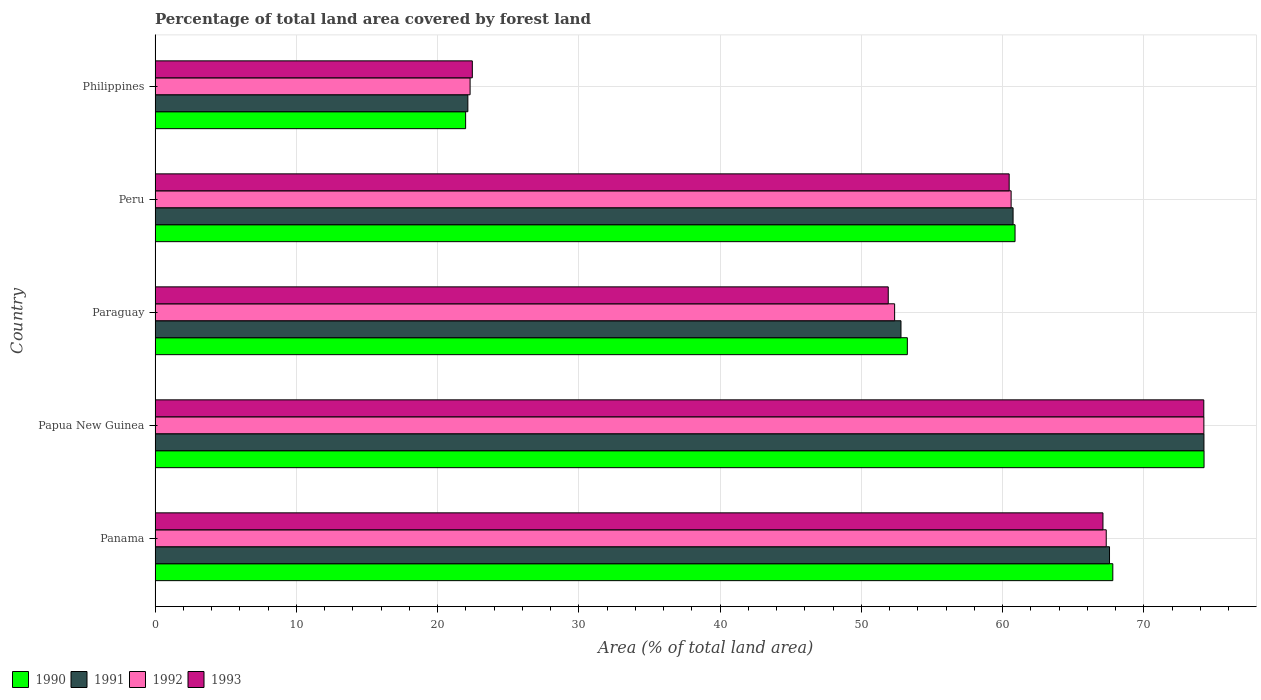Are the number of bars per tick equal to the number of legend labels?
Your answer should be very brief. Yes. How many bars are there on the 1st tick from the top?
Your response must be concise. 4. What is the label of the 3rd group of bars from the top?
Provide a short and direct response. Paraguay. In how many cases, is the number of bars for a given country not equal to the number of legend labels?
Provide a short and direct response. 0. What is the percentage of forest land in 1992 in Peru?
Offer a terse response. 60.6. Across all countries, what is the maximum percentage of forest land in 1993?
Ensure brevity in your answer.  74.24. Across all countries, what is the minimum percentage of forest land in 1990?
Your response must be concise. 21.98. In which country was the percentage of forest land in 1992 maximum?
Offer a terse response. Papua New Guinea. In which country was the percentage of forest land in 1992 minimum?
Your answer should be very brief. Philippines. What is the total percentage of forest land in 1991 in the graph?
Provide a short and direct response. 277.49. What is the difference between the percentage of forest land in 1993 in Panama and that in Peru?
Your answer should be very brief. 6.64. What is the difference between the percentage of forest land in 1991 in Peru and the percentage of forest land in 1993 in Philippines?
Your answer should be compact. 38.28. What is the average percentage of forest land in 1992 per country?
Keep it short and to the point. 55.36. What is the difference between the percentage of forest land in 1993 and percentage of forest land in 1991 in Papua New Guinea?
Your response must be concise. -0.01. In how many countries, is the percentage of forest land in 1991 greater than 58 %?
Keep it short and to the point. 3. What is the ratio of the percentage of forest land in 1991 in Panama to that in Paraguay?
Offer a terse response. 1.28. Is the percentage of forest land in 1992 in Peru less than that in Philippines?
Your answer should be very brief. No. What is the difference between the highest and the second highest percentage of forest land in 1990?
Keep it short and to the point. 6.46. What is the difference between the highest and the lowest percentage of forest land in 1991?
Keep it short and to the point. 52.11. In how many countries, is the percentage of forest land in 1990 greater than the average percentage of forest land in 1990 taken over all countries?
Your response must be concise. 3. Is the sum of the percentage of forest land in 1990 in Panama and Peru greater than the maximum percentage of forest land in 1992 across all countries?
Your response must be concise. Yes. What does the 3rd bar from the top in Philippines represents?
Your response must be concise. 1991. What does the 4th bar from the bottom in Papua New Guinea represents?
Ensure brevity in your answer.  1993. Is it the case that in every country, the sum of the percentage of forest land in 1993 and percentage of forest land in 1992 is greater than the percentage of forest land in 1990?
Provide a short and direct response. Yes. How many bars are there?
Offer a very short reply. 20. What is the difference between two consecutive major ticks on the X-axis?
Keep it short and to the point. 10. Are the values on the major ticks of X-axis written in scientific E-notation?
Offer a terse response. No. Does the graph contain grids?
Make the answer very short. Yes. What is the title of the graph?
Provide a succinct answer. Percentage of total land area covered by forest land. Does "2012" appear as one of the legend labels in the graph?
Your answer should be compact. No. What is the label or title of the X-axis?
Provide a short and direct response. Area (% of total land area). What is the Area (% of total land area) in 1990 in Panama?
Your answer should be compact. 67.8. What is the Area (% of total land area) in 1991 in Panama?
Provide a succinct answer. 67.56. What is the Area (% of total land area) of 1992 in Panama?
Provide a short and direct response. 67.33. What is the Area (% of total land area) of 1993 in Panama?
Your response must be concise. 67.1. What is the Area (% of total land area) of 1990 in Papua New Guinea?
Give a very brief answer. 74.25. What is the Area (% of total land area) in 1991 in Papua New Guinea?
Ensure brevity in your answer.  74.25. What is the Area (% of total land area) in 1992 in Papua New Guinea?
Offer a very short reply. 74.24. What is the Area (% of total land area) in 1993 in Papua New Guinea?
Give a very brief answer. 74.24. What is the Area (% of total land area) of 1990 in Paraguay?
Make the answer very short. 53.25. What is the Area (% of total land area) of 1991 in Paraguay?
Make the answer very short. 52.8. What is the Area (% of total land area) of 1992 in Paraguay?
Ensure brevity in your answer.  52.35. What is the Area (% of total land area) of 1993 in Paraguay?
Offer a terse response. 51.9. What is the Area (% of total land area) of 1990 in Peru?
Ensure brevity in your answer.  60.88. What is the Area (% of total land area) of 1991 in Peru?
Make the answer very short. 60.74. What is the Area (% of total land area) of 1992 in Peru?
Give a very brief answer. 60.6. What is the Area (% of total land area) in 1993 in Peru?
Your answer should be compact. 60.46. What is the Area (% of total land area) of 1990 in Philippines?
Ensure brevity in your answer.  21.98. What is the Area (% of total land area) in 1991 in Philippines?
Keep it short and to the point. 22.14. What is the Area (% of total land area) in 1992 in Philippines?
Keep it short and to the point. 22.3. What is the Area (% of total land area) in 1993 in Philippines?
Ensure brevity in your answer.  22.46. Across all countries, what is the maximum Area (% of total land area) of 1990?
Offer a terse response. 74.25. Across all countries, what is the maximum Area (% of total land area) of 1991?
Offer a terse response. 74.25. Across all countries, what is the maximum Area (% of total land area) of 1992?
Your answer should be compact. 74.24. Across all countries, what is the maximum Area (% of total land area) of 1993?
Make the answer very short. 74.24. Across all countries, what is the minimum Area (% of total land area) of 1990?
Offer a terse response. 21.98. Across all countries, what is the minimum Area (% of total land area) of 1991?
Your answer should be compact. 22.14. Across all countries, what is the minimum Area (% of total land area) in 1992?
Offer a very short reply. 22.3. Across all countries, what is the minimum Area (% of total land area) in 1993?
Your answer should be very brief. 22.46. What is the total Area (% of total land area) of 1990 in the graph?
Ensure brevity in your answer.  278.16. What is the total Area (% of total land area) in 1991 in the graph?
Give a very brief answer. 277.49. What is the total Area (% of total land area) of 1992 in the graph?
Offer a terse response. 276.82. What is the total Area (% of total land area) in 1993 in the graph?
Ensure brevity in your answer.  276.16. What is the difference between the Area (% of total land area) in 1990 in Panama and that in Papua New Guinea?
Your answer should be very brief. -6.46. What is the difference between the Area (% of total land area) in 1991 in Panama and that in Papua New Guinea?
Offer a terse response. -6.68. What is the difference between the Area (% of total land area) in 1992 in Panama and that in Papua New Guinea?
Ensure brevity in your answer.  -6.91. What is the difference between the Area (% of total land area) of 1993 in Panama and that in Papua New Guinea?
Offer a very short reply. -7.14. What is the difference between the Area (% of total land area) in 1990 in Panama and that in Paraguay?
Provide a short and direct response. 14.54. What is the difference between the Area (% of total land area) of 1991 in Panama and that in Paraguay?
Your answer should be compact. 14.76. What is the difference between the Area (% of total land area) in 1992 in Panama and that in Paraguay?
Keep it short and to the point. 14.98. What is the difference between the Area (% of total land area) in 1993 in Panama and that in Paraguay?
Your answer should be very brief. 15.2. What is the difference between the Area (% of total land area) in 1990 in Panama and that in Peru?
Make the answer very short. 6.92. What is the difference between the Area (% of total land area) of 1991 in Panama and that in Peru?
Provide a short and direct response. 6.83. What is the difference between the Area (% of total land area) in 1992 in Panama and that in Peru?
Give a very brief answer. 6.73. What is the difference between the Area (% of total land area) of 1993 in Panama and that in Peru?
Your answer should be very brief. 6.64. What is the difference between the Area (% of total land area) of 1990 in Panama and that in Philippines?
Make the answer very short. 45.81. What is the difference between the Area (% of total land area) of 1991 in Panama and that in Philippines?
Ensure brevity in your answer.  45.42. What is the difference between the Area (% of total land area) of 1992 in Panama and that in Philippines?
Your answer should be compact. 45.03. What is the difference between the Area (% of total land area) of 1993 in Panama and that in Philippines?
Offer a very short reply. 44.64. What is the difference between the Area (% of total land area) of 1990 in Papua New Guinea and that in Paraguay?
Provide a short and direct response. 21. What is the difference between the Area (% of total land area) in 1991 in Papua New Guinea and that in Paraguay?
Offer a very short reply. 21.45. What is the difference between the Area (% of total land area) of 1992 in Papua New Guinea and that in Paraguay?
Give a very brief answer. 21.89. What is the difference between the Area (% of total land area) of 1993 in Papua New Guinea and that in Paraguay?
Provide a succinct answer. 22.34. What is the difference between the Area (% of total land area) of 1990 in Papua New Guinea and that in Peru?
Offer a very short reply. 13.38. What is the difference between the Area (% of total land area) of 1991 in Papua New Guinea and that in Peru?
Offer a terse response. 13.51. What is the difference between the Area (% of total land area) of 1992 in Papua New Guinea and that in Peru?
Provide a short and direct response. 13.64. What is the difference between the Area (% of total land area) in 1993 in Papua New Guinea and that in Peru?
Your response must be concise. 13.78. What is the difference between the Area (% of total land area) of 1990 in Papua New Guinea and that in Philippines?
Provide a succinct answer. 52.27. What is the difference between the Area (% of total land area) of 1991 in Papua New Guinea and that in Philippines?
Provide a short and direct response. 52.11. What is the difference between the Area (% of total land area) in 1992 in Papua New Guinea and that in Philippines?
Keep it short and to the point. 51.94. What is the difference between the Area (% of total land area) in 1993 in Papua New Guinea and that in Philippines?
Keep it short and to the point. 51.78. What is the difference between the Area (% of total land area) of 1990 in Paraguay and that in Peru?
Keep it short and to the point. -7.62. What is the difference between the Area (% of total land area) of 1991 in Paraguay and that in Peru?
Offer a terse response. -7.94. What is the difference between the Area (% of total land area) in 1992 in Paraguay and that in Peru?
Offer a very short reply. -8.25. What is the difference between the Area (% of total land area) of 1993 in Paraguay and that in Peru?
Offer a terse response. -8.56. What is the difference between the Area (% of total land area) in 1990 in Paraguay and that in Philippines?
Give a very brief answer. 31.27. What is the difference between the Area (% of total land area) in 1991 in Paraguay and that in Philippines?
Give a very brief answer. 30.66. What is the difference between the Area (% of total land area) of 1992 in Paraguay and that in Philippines?
Provide a short and direct response. 30.05. What is the difference between the Area (% of total land area) of 1993 in Paraguay and that in Philippines?
Offer a terse response. 29.44. What is the difference between the Area (% of total land area) in 1990 in Peru and that in Philippines?
Give a very brief answer. 38.89. What is the difference between the Area (% of total land area) in 1991 in Peru and that in Philippines?
Your answer should be very brief. 38.59. What is the difference between the Area (% of total land area) of 1992 in Peru and that in Philippines?
Provide a short and direct response. 38.3. What is the difference between the Area (% of total land area) in 1993 in Peru and that in Philippines?
Your answer should be very brief. 38. What is the difference between the Area (% of total land area) in 1990 in Panama and the Area (% of total land area) in 1991 in Papua New Guinea?
Your response must be concise. -6.45. What is the difference between the Area (% of total land area) in 1990 in Panama and the Area (% of total land area) in 1992 in Papua New Guinea?
Your response must be concise. -6.45. What is the difference between the Area (% of total land area) in 1990 in Panama and the Area (% of total land area) in 1993 in Papua New Guinea?
Offer a very short reply. -6.44. What is the difference between the Area (% of total land area) in 1991 in Panama and the Area (% of total land area) in 1992 in Papua New Guinea?
Offer a terse response. -6.68. What is the difference between the Area (% of total land area) in 1991 in Panama and the Area (% of total land area) in 1993 in Papua New Guinea?
Ensure brevity in your answer.  -6.67. What is the difference between the Area (% of total land area) of 1992 in Panama and the Area (% of total land area) of 1993 in Papua New Guinea?
Provide a short and direct response. -6.91. What is the difference between the Area (% of total land area) of 1990 in Panama and the Area (% of total land area) of 1991 in Paraguay?
Your response must be concise. 14.99. What is the difference between the Area (% of total land area) of 1990 in Panama and the Area (% of total land area) of 1992 in Paraguay?
Provide a succinct answer. 15.45. What is the difference between the Area (% of total land area) of 1990 in Panama and the Area (% of total land area) of 1993 in Paraguay?
Give a very brief answer. 15.9. What is the difference between the Area (% of total land area) in 1991 in Panama and the Area (% of total land area) in 1992 in Paraguay?
Provide a succinct answer. 15.21. What is the difference between the Area (% of total land area) in 1991 in Panama and the Area (% of total land area) in 1993 in Paraguay?
Provide a succinct answer. 15.66. What is the difference between the Area (% of total land area) in 1992 in Panama and the Area (% of total land area) in 1993 in Paraguay?
Offer a very short reply. 15.43. What is the difference between the Area (% of total land area) in 1990 in Panama and the Area (% of total land area) in 1991 in Peru?
Your answer should be compact. 7.06. What is the difference between the Area (% of total land area) in 1990 in Panama and the Area (% of total land area) in 1992 in Peru?
Make the answer very short. 7.2. What is the difference between the Area (% of total land area) in 1990 in Panama and the Area (% of total land area) in 1993 in Peru?
Provide a succinct answer. 7.34. What is the difference between the Area (% of total land area) of 1991 in Panama and the Area (% of total land area) of 1992 in Peru?
Ensure brevity in your answer.  6.97. What is the difference between the Area (% of total land area) of 1991 in Panama and the Area (% of total land area) of 1993 in Peru?
Provide a short and direct response. 7.1. What is the difference between the Area (% of total land area) of 1992 in Panama and the Area (% of total land area) of 1993 in Peru?
Provide a short and direct response. 6.87. What is the difference between the Area (% of total land area) of 1990 in Panama and the Area (% of total land area) of 1991 in Philippines?
Provide a short and direct response. 45.65. What is the difference between the Area (% of total land area) in 1990 in Panama and the Area (% of total land area) in 1992 in Philippines?
Provide a short and direct response. 45.5. What is the difference between the Area (% of total land area) in 1990 in Panama and the Area (% of total land area) in 1993 in Philippines?
Your answer should be very brief. 45.34. What is the difference between the Area (% of total land area) of 1991 in Panama and the Area (% of total land area) of 1992 in Philippines?
Make the answer very short. 45.26. What is the difference between the Area (% of total land area) of 1991 in Panama and the Area (% of total land area) of 1993 in Philippines?
Your answer should be very brief. 45.1. What is the difference between the Area (% of total land area) in 1992 in Panama and the Area (% of total land area) in 1993 in Philippines?
Your response must be concise. 44.87. What is the difference between the Area (% of total land area) in 1990 in Papua New Guinea and the Area (% of total land area) in 1991 in Paraguay?
Provide a succinct answer. 21.45. What is the difference between the Area (% of total land area) of 1990 in Papua New Guinea and the Area (% of total land area) of 1992 in Paraguay?
Offer a terse response. 21.9. What is the difference between the Area (% of total land area) in 1990 in Papua New Guinea and the Area (% of total land area) in 1993 in Paraguay?
Offer a terse response. 22.35. What is the difference between the Area (% of total land area) of 1991 in Papua New Guinea and the Area (% of total land area) of 1992 in Paraguay?
Offer a very short reply. 21.9. What is the difference between the Area (% of total land area) of 1991 in Papua New Guinea and the Area (% of total land area) of 1993 in Paraguay?
Make the answer very short. 22.35. What is the difference between the Area (% of total land area) in 1992 in Papua New Guinea and the Area (% of total land area) in 1993 in Paraguay?
Your answer should be compact. 22.34. What is the difference between the Area (% of total land area) of 1990 in Papua New Guinea and the Area (% of total land area) of 1991 in Peru?
Give a very brief answer. 13.52. What is the difference between the Area (% of total land area) in 1990 in Papua New Guinea and the Area (% of total land area) in 1992 in Peru?
Provide a short and direct response. 13.66. What is the difference between the Area (% of total land area) of 1990 in Papua New Guinea and the Area (% of total land area) of 1993 in Peru?
Provide a succinct answer. 13.79. What is the difference between the Area (% of total land area) of 1991 in Papua New Guinea and the Area (% of total land area) of 1992 in Peru?
Offer a terse response. 13.65. What is the difference between the Area (% of total land area) in 1991 in Papua New Guinea and the Area (% of total land area) in 1993 in Peru?
Give a very brief answer. 13.79. What is the difference between the Area (% of total land area) of 1992 in Papua New Guinea and the Area (% of total land area) of 1993 in Peru?
Your answer should be compact. 13.78. What is the difference between the Area (% of total land area) in 1990 in Papua New Guinea and the Area (% of total land area) in 1991 in Philippines?
Offer a very short reply. 52.11. What is the difference between the Area (% of total land area) of 1990 in Papua New Guinea and the Area (% of total land area) of 1992 in Philippines?
Your response must be concise. 51.95. What is the difference between the Area (% of total land area) of 1990 in Papua New Guinea and the Area (% of total land area) of 1993 in Philippines?
Your answer should be compact. 51.8. What is the difference between the Area (% of total land area) in 1991 in Papua New Guinea and the Area (% of total land area) in 1992 in Philippines?
Make the answer very short. 51.95. What is the difference between the Area (% of total land area) in 1991 in Papua New Guinea and the Area (% of total land area) in 1993 in Philippines?
Your answer should be compact. 51.79. What is the difference between the Area (% of total land area) of 1992 in Papua New Guinea and the Area (% of total land area) of 1993 in Philippines?
Your response must be concise. 51.78. What is the difference between the Area (% of total land area) in 1990 in Paraguay and the Area (% of total land area) in 1991 in Peru?
Your answer should be very brief. -7.49. What is the difference between the Area (% of total land area) of 1990 in Paraguay and the Area (% of total land area) of 1992 in Peru?
Offer a terse response. -7.35. What is the difference between the Area (% of total land area) in 1990 in Paraguay and the Area (% of total land area) in 1993 in Peru?
Offer a very short reply. -7.21. What is the difference between the Area (% of total land area) in 1991 in Paraguay and the Area (% of total land area) in 1992 in Peru?
Ensure brevity in your answer.  -7.8. What is the difference between the Area (% of total land area) of 1991 in Paraguay and the Area (% of total land area) of 1993 in Peru?
Provide a succinct answer. -7.66. What is the difference between the Area (% of total land area) of 1992 in Paraguay and the Area (% of total land area) of 1993 in Peru?
Your answer should be compact. -8.11. What is the difference between the Area (% of total land area) in 1990 in Paraguay and the Area (% of total land area) in 1991 in Philippines?
Offer a terse response. 31.11. What is the difference between the Area (% of total land area) of 1990 in Paraguay and the Area (% of total land area) of 1992 in Philippines?
Keep it short and to the point. 30.95. What is the difference between the Area (% of total land area) in 1990 in Paraguay and the Area (% of total land area) in 1993 in Philippines?
Keep it short and to the point. 30.79. What is the difference between the Area (% of total land area) in 1991 in Paraguay and the Area (% of total land area) in 1992 in Philippines?
Keep it short and to the point. 30.5. What is the difference between the Area (% of total land area) in 1991 in Paraguay and the Area (% of total land area) in 1993 in Philippines?
Your answer should be very brief. 30.34. What is the difference between the Area (% of total land area) in 1992 in Paraguay and the Area (% of total land area) in 1993 in Philippines?
Your answer should be very brief. 29.89. What is the difference between the Area (% of total land area) of 1990 in Peru and the Area (% of total land area) of 1991 in Philippines?
Provide a short and direct response. 38.73. What is the difference between the Area (% of total land area) in 1990 in Peru and the Area (% of total land area) in 1992 in Philippines?
Make the answer very short. 38.58. What is the difference between the Area (% of total land area) of 1990 in Peru and the Area (% of total land area) of 1993 in Philippines?
Your response must be concise. 38.42. What is the difference between the Area (% of total land area) of 1991 in Peru and the Area (% of total land area) of 1992 in Philippines?
Provide a short and direct response. 38.44. What is the difference between the Area (% of total land area) in 1991 in Peru and the Area (% of total land area) in 1993 in Philippines?
Your response must be concise. 38.28. What is the difference between the Area (% of total land area) in 1992 in Peru and the Area (% of total land area) in 1993 in Philippines?
Give a very brief answer. 38.14. What is the average Area (% of total land area) of 1990 per country?
Keep it short and to the point. 55.63. What is the average Area (% of total land area) of 1991 per country?
Give a very brief answer. 55.5. What is the average Area (% of total land area) in 1992 per country?
Your response must be concise. 55.36. What is the average Area (% of total land area) in 1993 per country?
Ensure brevity in your answer.  55.23. What is the difference between the Area (% of total land area) of 1990 and Area (% of total land area) of 1991 in Panama?
Provide a succinct answer. 0.23. What is the difference between the Area (% of total land area) of 1990 and Area (% of total land area) of 1992 in Panama?
Keep it short and to the point. 0.47. What is the difference between the Area (% of total land area) in 1990 and Area (% of total land area) in 1993 in Panama?
Your answer should be very brief. 0.7. What is the difference between the Area (% of total land area) in 1991 and Area (% of total land area) in 1992 in Panama?
Your answer should be compact. 0.23. What is the difference between the Area (% of total land area) in 1991 and Area (% of total land area) in 1993 in Panama?
Your answer should be very brief. 0.47. What is the difference between the Area (% of total land area) of 1992 and Area (% of total land area) of 1993 in Panama?
Offer a terse response. 0.23. What is the difference between the Area (% of total land area) in 1990 and Area (% of total land area) in 1991 in Papua New Guinea?
Give a very brief answer. 0.01. What is the difference between the Area (% of total land area) of 1990 and Area (% of total land area) of 1992 in Papua New Guinea?
Give a very brief answer. 0.01. What is the difference between the Area (% of total land area) of 1990 and Area (% of total land area) of 1993 in Papua New Guinea?
Your answer should be very brief. 0.02. What is the difference between the Area (% of total land area) of 1991 and Area (% of total land area) of 1992 in Papua New Guinea?
Ensure brevity in your answer.  0.01. What is the difference between the Area (% of total land area) in 1991 and Area (% of total land area) in 1993 in Papua New Guinea?
Your answer should be compact. 0.01. What is the difference between the Area (% of total land area) of 1992 and Area (% of total land area) of 1993 in Papua New Guinea?
Offer a terse response. 0.01. What is the difference between the Area (% of total land area) of 1990 and Area (% of total land area) of 1991 in Paraguay?
Offer a very short reply. 0.45. What is the difference between the Area (% of total land area) in 1990 and Area (% of total land area) in 1992 in Paraguay?
Give a very brief answer. 0.9. What is the difference between the Area (% of total land area) of 1990 and Area (% of total land area) of 1993 in Paraguay?
Give a very brief answer. 1.35. What is the difference between the Area (% of total land area) of 1991 and Area (% of total land area) of 1992 in Paraguay?
Provide a short and direct response. 0.45. What is the difference between the Area (% of total land area) in 1991 and Area (% of total land area) in 1993 in Paraguay?
Your answer should be compact. 0.9. What is the difference between the Area (% of total land area) in 1992 and Area (% of total land area) in 1993 in Paraguay?
Your response must be concise. 0.45. What is the difference between the Area (% of total land area) of 1990 and Area (% of total land area) of 1991 in Peru?
Provide a succinct answer. 0.14. What is the difference between the Area (% of total land area) in 1990 and Area (% of total land area) in 1992 in Peru?
Your response must be concise. 0.28. What is the difference between the Area (% of total land area) in 1990 and Area (% of total land area) in 1993 in Peru?
Make the answer very short. 0.42. What is the difference between the Area (% of total land area) of 1991 and Area (% of total land area) of 1992 in Peru?
Give a very brief answer. 0.14. What is the difference between the Area (% of total land area) of 1991 and Area (% of total land area) of 1993 in Peru?
Give a very brief answer. 0.28. What is the difference between the Area (% of total land area) of 1992 and Area (% of total land area) of 1993 in Peru?
Ensure brevity in your answer.  0.14. What is the difference between the Area (% of total land area) in 1990 and Area (% of total land area) in 1991 in Philippines?
Provide a succinct answer. -0.16. What is the difference between the Area (% of total land area) of 1990 and Area (% of total land area) of 1992 in Philippines?
Your response must be concise. -0.32. What is the difference between the Area (% of total land area) in 1990 and Area (% of total land area) in 1993 in Philippines?
Provide a short and direct response. -0.47. What is the difference between the Area (% of total land area) in 1991 and Area (% of total land area) in 1992 in Philippines?
Your answer should be very brief. -0.16. What is the difference between the Area (% of total land area) in 1991 and Area (% of total land area) in 1993 in Philippines?
Offer a very short reply. -0.32. What is the difference between the Area (% of total land area) in 1992 and Area (% of total land area) in 1993 in Philippines?
Your answer should be compact. -0.16. What is the ratio of the Area (% of total land area) of 1991 in Panama to that in Papua New Guinea?
Ensure brevity in your answer.  0.91. What is the ratio of the Area (% of total land area) in 1992 in Panama to that in Papua New Guinea?
Your answer should be very brief. 0.91. What is the ratio of the Area (% of total land area) in 1993 in Panama to that in Papua New Guinea?
Provide a short and direct response. 0.9. What is the ratio of the Area (% of total land area) in 1990 in Panama to that in Paraguay?
Offer a terse response. 1.27. What is the ratio of the Area (% of total land area) of 1991 in Panama to that in Paraguay?
Your answer should be very brief. 1.28. What is the ratio of the Area (% of total land area) of 1992 in Panama to that in Paraguay?
Provide a succinct answer. 1.29. What is the ratio of the Area (% of total land area) of 1993 in Panama to that in Paraguay?
Keep it short and to the point. 1.29. What is the ratio of the Area (% of total land area) of 1990 in Panama to that in Peru?
Provide a short and direct response. 1.11. What is the ratio of the Area (% of total land area) of 1991 in Panama to that in Peru?
Keep it short and to the point. 1.11. What is the ratio of the Area (% of total land area) of 1992 in Panama to that in Peru?
Ensure brevity in your answer.  1.11. What is the ratio of the Area (% of total land area) in 1993 in Panama to that in Peru?
Give a very brief answer. 1.11. What is the ratio of the Area (% of total land area) of 1990 in Panama to that in Philippines?
Provide a succinct answer. 3.08. What is the ratio of the Area (% of total land area) of 1991 in Panama to that in Philippines?
Your response must be concise. 3.05. What is the ratio of the Area (% of total land area) of 1992 in Panama to that in Philippines?
Provide a short and direct response. 3.02. What is the ratio of the Area (% of total land area) in 1993 in Panama to that in Philippines?
Provide a short and direct response. 2.99. What is the ratio of the Area (% of total land area) in 1990 in Papua New Guinea to that in Paraguay?
Ensure brevity in your answer.  1.39. What is the ratio of the Area (% of total land area) of 1991 in Papua New Guinea to that in Paraguay?
Provide a succinct answer. 1.41. What is the ratio of the Area (% of total land area) of 1992 in Papua New Guinea to that in Paraguay?
Your response must be concise. 1.42. What is the ratio of the Area (% of total land area) of 1993 in Papua New Guinea to that in Paraguay?
Ensure brevity in your answer.  1.43. What is the ratio of the Area (% of total land area) in 1990 in Papua New Guinea to that in Peru?
Your response must be concise. 1.22. What is the ratio of the Area (% of total land area) in 1991 in Papua New Guinea to that in Peru?
Make the answer very short. 1.22. What is the ratio of the Area (% of total land area) of 1992 in Papua New Guinea to that in Peru?
Ensure brevity in your answer.  1.23. What is the ratio of the Area (% of total land area) in 1993 in Papua New Guinea to that in Peru?
Your answer should be compact. 1.23. What is the ratio of the Area (% of total land area) in 1990 in Papua New Guinea to that in Philippines?
Ensure brevity in your answer.  3.38. What is the ratio of the Area (% of total land area) in 1991 in Papua New Guinea to that in Philippines?
Your answer should be very brief. 3.35. What is the ratio of the Area (% of total land area) of 1992 in Papua New Guinea to that in Philippines?
Provide a succinct answer. 3.33. What is the ratio of the Area (% of total land area) in 1993 in Papua New Guinea to that in Philippines?
Offer a very short reply. 3.31. What is the ratio of the Area (% of total land area) in 1990 in Paraguay to that in Peru?
Offer a terse response. 0.87. What is the ratio of the Area (% of total land area) of 1991 in Paraguay to that in Peru?
Keep it short and to the point. 0.87. What is the ratio of the Area (% of total land area) in 1992 in Paraguay to that in Peru?
Offer a very short reply. 0.86. What is the ratio of the Area (% of total land area) in 1993 in Paraguay to that in Peru?
Your answer should be compact. 0.86. What is the ratio of the Area (% of total land area) in 1990 in Paraguay to that in Philippines?
Your answer should be compact. 2.42. What is the ratio of the Area (% of total land area) in 1991 in Paraguay to that in Philippines?
Your response must be concise. 2.38. What is the ratio of the Area (% of total land area) in 1992 in Paraguay to that in Philippines?
Provide a succinct answer. 2.35. What is the ratio of the Area (% of total land area) of 1993 in Paraguay to that in Philippines?
Provide a succinct answer. 2.31. What is the ratio of the Area (% of total land area) of 1990 in Peru to that in Philippines?
Your answer should be very brief. 2.77. What is the ratio of the Area (% of total land area) in 1991 in Peru to that in Philippines?
Your response must be concise. 2.74. What is the ratio of the Area (% of total land area) of 1992 in Peru to that in Philippines?
Provide a succinct answer. 2.72. What is the ratio of the Area (% of total land area) of 1993 in Peru to that in Philippines?
Your answer should be compact. 2.69. What is the difference between the highest and the second highest Area (% of total land area) of 1990?
Your response must be concise. 6.46. What is the difference between the highest and the second highest Area (% of total land area) of 1991?
Offer a terse response. 6.68. What is the difference between the highest and the second highest Area (% of total land area) in 1992?
Your response must be concise. 6.91. What is the difference between the highest and the second highest Area (% of total land area) of 1993?
Ensure brevity in your answer.  7.14. What is the difference between the highest and the lowest Area (% of total land area) of 1990?
Provide a succinct answer. 52.27. What is the difference between the highest and the lowest Area (% of total land area) in 1991?
Give a very brief answer. 52.11. What is the difference between the highest and the lowest Area (% of total land area) of 1992?
Your answer should be compact. 51.94. What is the difference between the highest and the lowest Area (% of total land area) in 1993?
Ensure brevity in your answer.  51.78. 